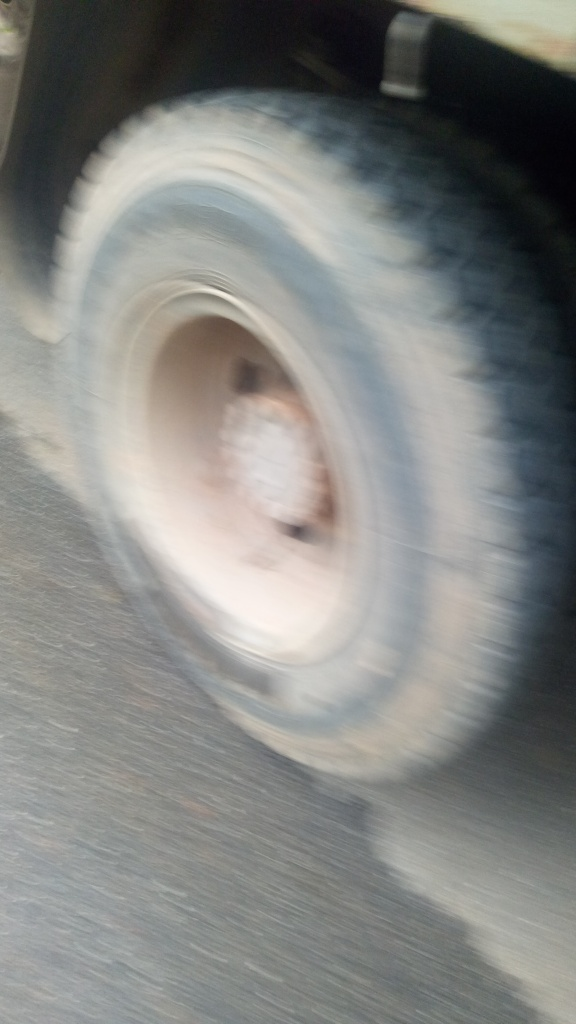Is there anything we can determine about the physical condition of the tire? Due to the lack of clarity, we can't make accurate judgments about the tire's condition. We cannot see if the tire has adequate tread, any visible damage, or if it's properly inflated. The condition of the tire, and any potential safety concerns, remain indeterminable from this image. 